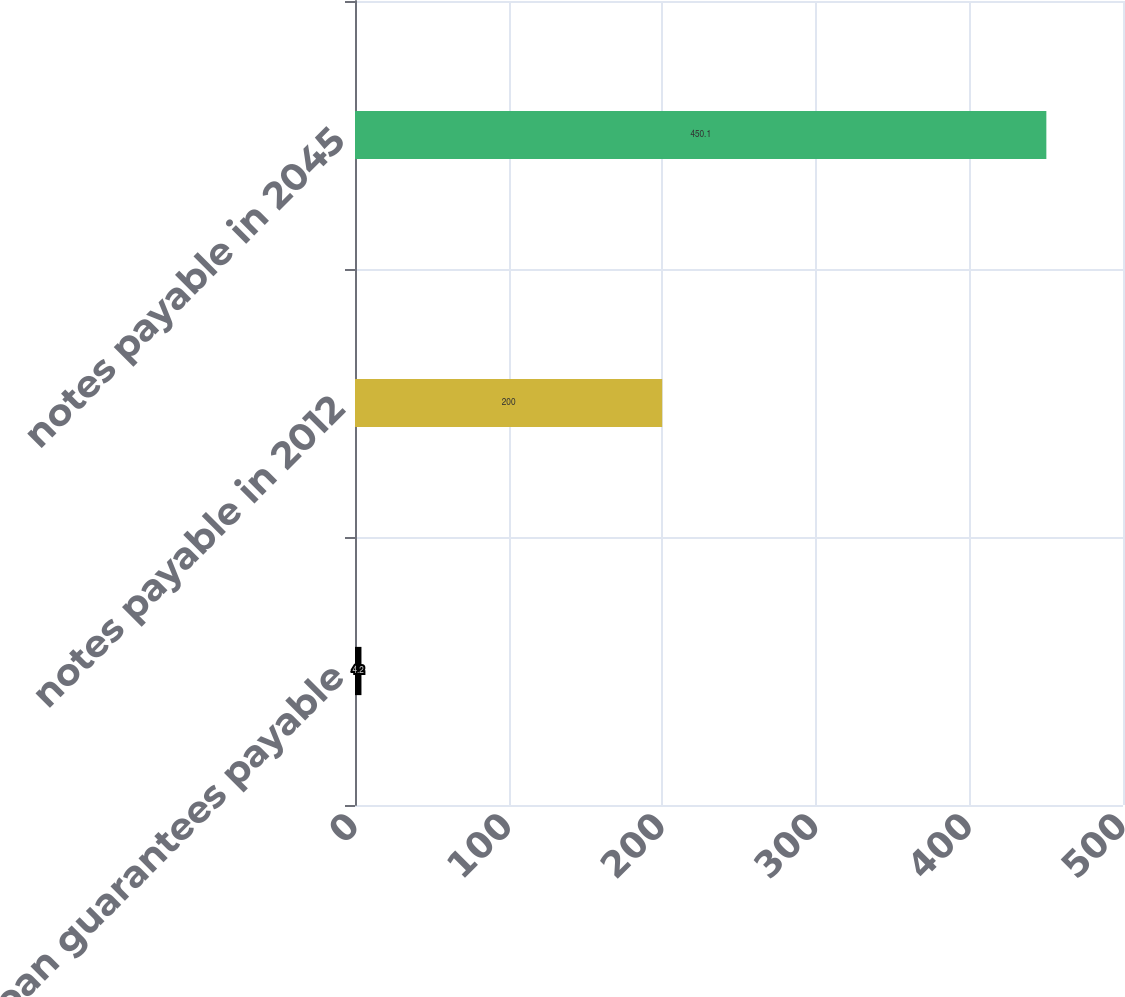<chart> <loc_0><loc_0><loc_500><loc_500><bar_chart><fcel>eSop loan guarantees payable<fcel>notes payable in 2012<fcel>notes payable in 2045<nl><fcel>4.2<fcel>200<fcel>450.1<nl></chart> 